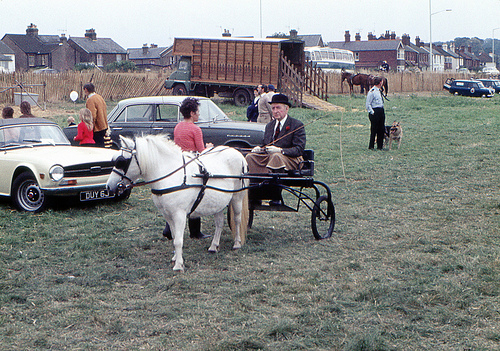What is the setting of this image? The image depicts an outdoor setting, likely a park or a rural fairground. There are people in the background who may be attendees or participants of a possible event. There's also a brown truck and some classic cars, suggesting a vintage era or a gathering for antique vehicle enthusiasts. What activities might be taking place here? Given the presence of the horse-drawn buggy and the vintage vehicles, this could be an outdoor exhibition, fair, or a meetup for historic vehicle and equine enthusiasts. Activities might include carriage rides, vehicle display, and perhaps competitions or informal gatherings to appreciate the classic designs and traditional modes of transportation. 